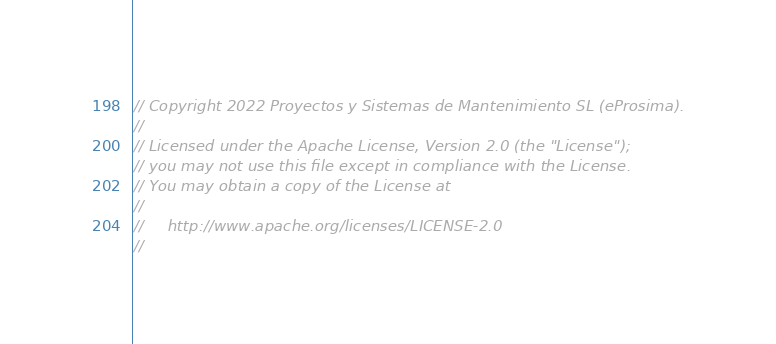Convert code to text. <code><loc_0><loc_0><loc_500><loc_500><_C++_>// Copyright 2022 Proyectos y Sistemas de Mantenimiento SL (eProsima).
//
// Licensed under the Apache License, Version 2.0 (the "License");
// you may not use this file except in compliance with the License.
// You may obtain a copy of the License at
//
//     http://www.apache.org/licenses/LICENSE-2.0
//</code> 